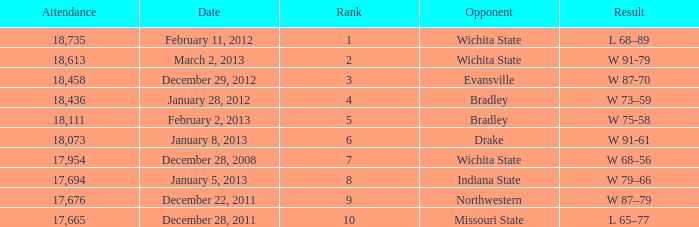Could you help me parse every detail presented in this table? {'header': ['Attendance', 'Date', 'Rank', 'Opponent', 'Result'], 'rows': [['18,735', 'February 11, 2012', '1', 'Wichita State', 'L 68–89'], ['18,613', 'March 2, 2013', '2', 'Wichita State', 'W 91-79'], ['18,458', 'December 29, 2012', '3', 'Evansville', 'W 87-70'], ['18,436', 'January 28, 2012', '4', 'Bradley', 'W 73–59'], ['18,111', 'February 2, 2013', '5', 'Bradley', 'W 75-58'], ['18,073', 'January 8, 2013', '6', 'Drake', 'W 91-61'], ['17,954', 'December 28, 2008', '7', 'Wichita State', 'W 68–56'], ['17,694', 'January 5, 2013', '8', 'Indiana State', 'W 79–66'], ['17,676', 'December 22, 2011', '9', 'Northwestern', 'W 87–79'], ['17,665', 'December 28, 2011', '10', 'Missouri State', 'L 65–77']]} What is the ranking when the attendance is below 18,073 and northwestern is the opposing team? 9.0. 